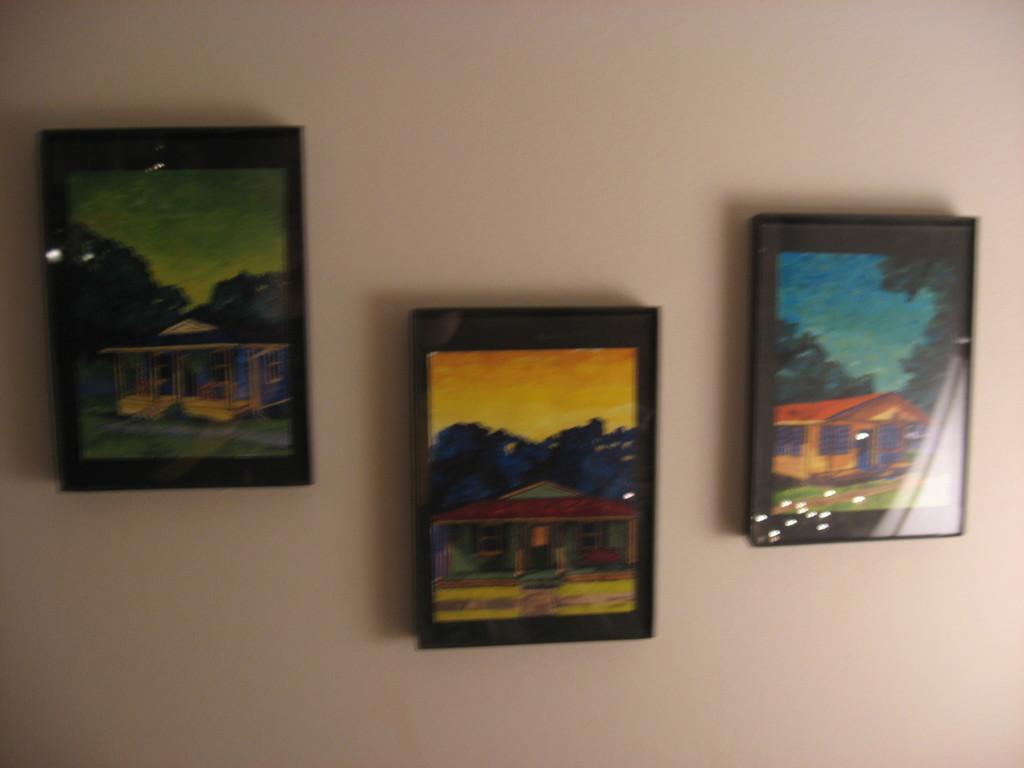Could you give a brief overview of what you see in this image? In this picture I can see photo frames attached to the wall. 